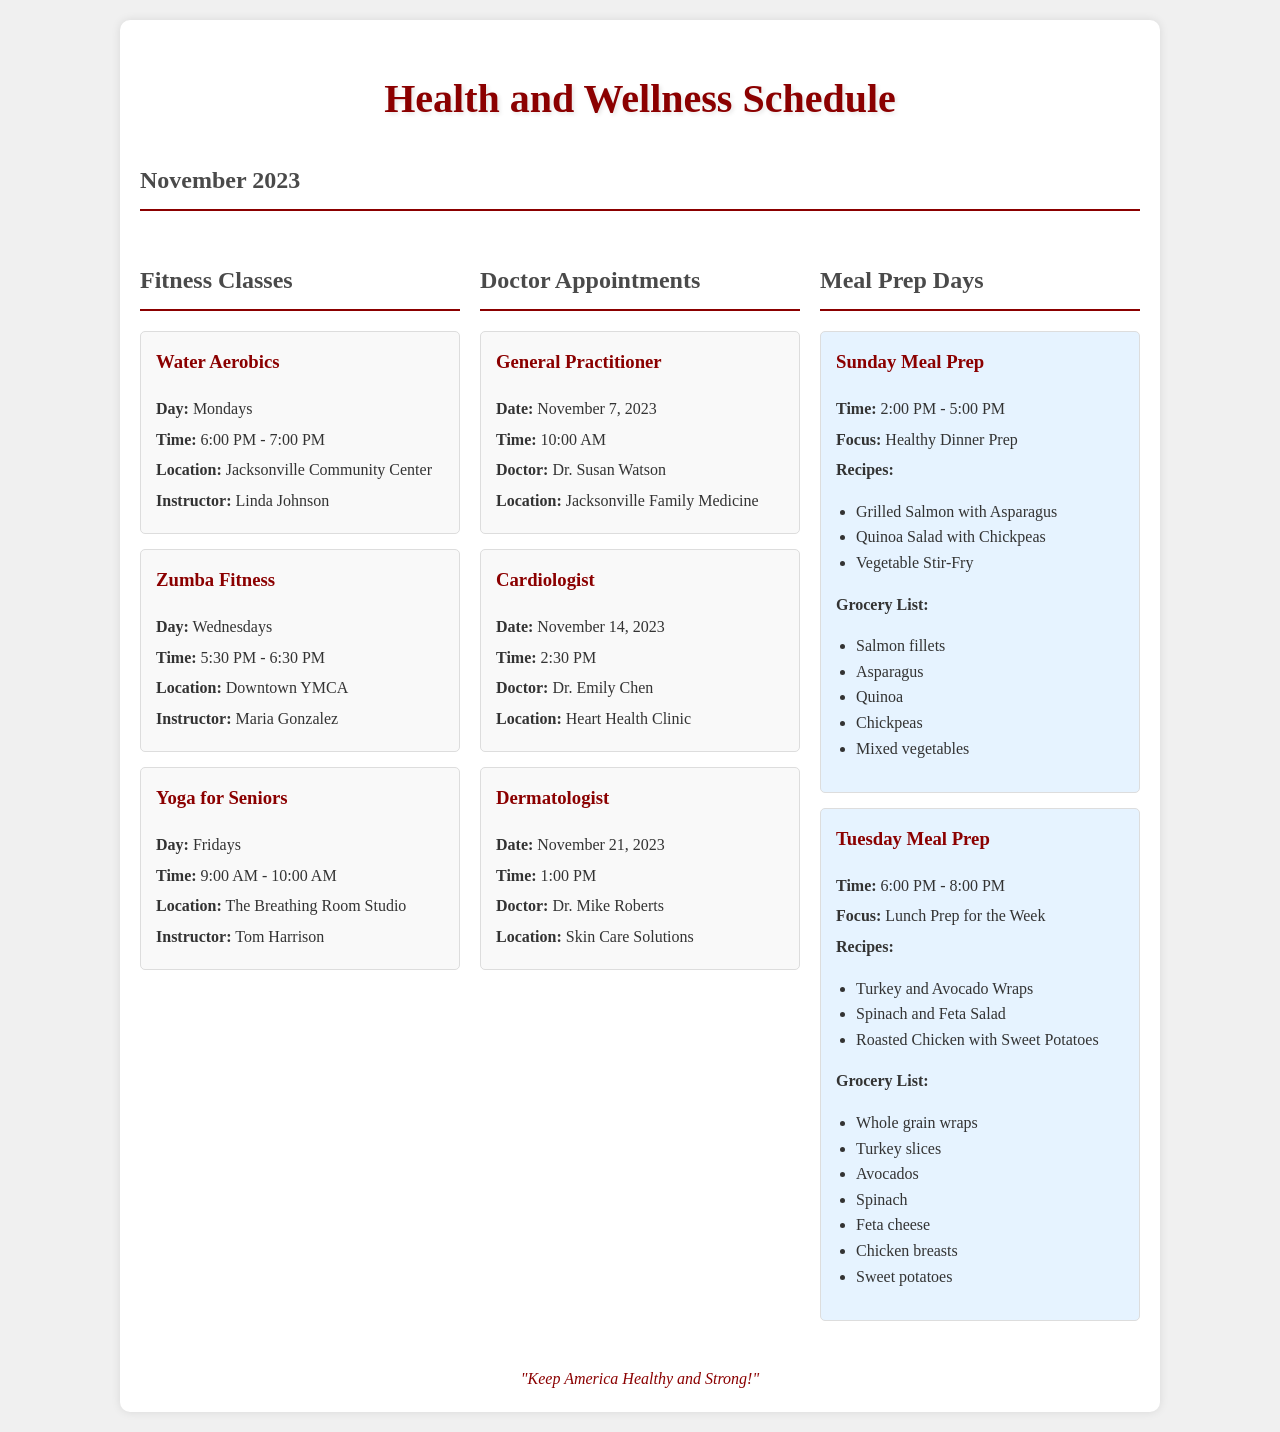What day is Water Aerobics? The schedule for Water Aerobics is listed under Fitness Classes, which occurs on Mondays.
Answer: Mondays Who instructs Yoga for Seniors? The instructor for Yoga for Seniors is mentioned in the Fitness Classes section, which is Tom Harrison.
Answer: Tom Harrison When is the General Practitioner appointment? The date and time for the General Practitioner appointment can be found under Doctor Appointments, which is November 7, 2023, at 10:00 AM.
Answer: November 7, 2023 What is the focus of the Sunday Meal Prep? The focus of Meal Prep for Sunday is specified as Healthy Dinner Prep.
Answer: Healthy Dinner Prep What time does Zumba Fitness start? The start time for Zumba Fitness is provided in the Fitness Classes section, which is at 5:30 PM.
Answer: 5:30 PM How many meals are listed for Tuesday Meal Prep? The number of meals for Tuesday Meal Prep can be found under the Recipes section, which lists three meals.
Answer: Three What is the name of the Cardiologist? The Cardiologist's name is included in the Doctor Appointments section, which is Dr. Emily Chen.
Answer: Dr. Emily Chen What is the grocery item needed for Sunday Meal Prep? One grocery item for Sunday Meal Prep is mentioned, which is Salmon fillets.
Answer: Salmon fillets What activity takes place on Fridays? The activity scheduled for Fridays is identified in the Fitness Classes, which is Yoga for Seniors.
Answer: Yoga for Seniors 